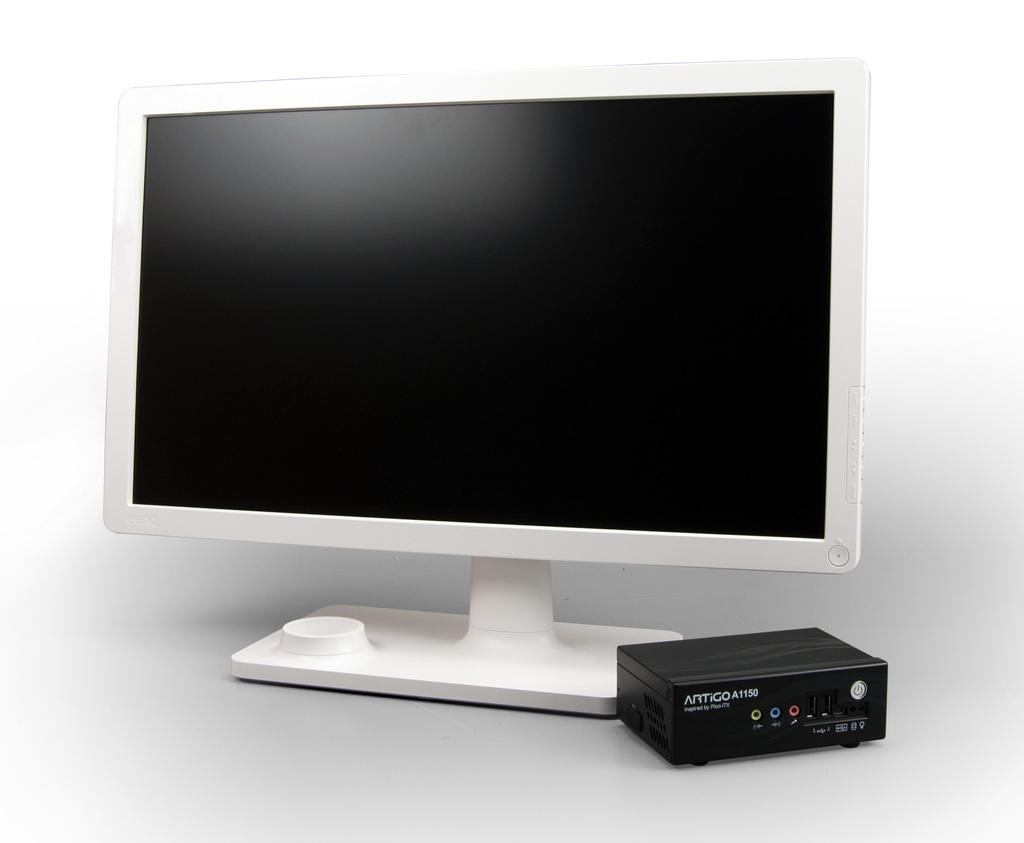<image>
Offer a succinct explanation of the picture presented. A small component is made by the ARTIGO corporation. 